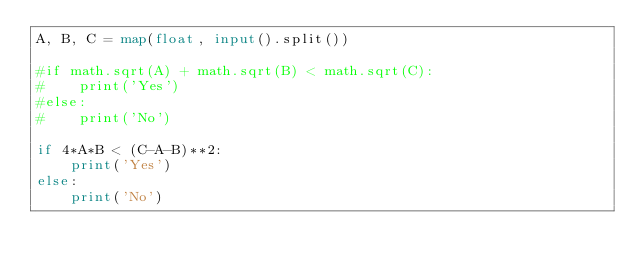Convert code to text. <code><loc_0><loc_0><loc_500><loc_500><_Python_>A, B, C = map(float, input().split())

#if math.sqrt(A) + math.sqrt(B) < math.sqrt(C):
#    print('Yes')
#else:
#    print('No')

if 4*A*B < (C-A-B)**2:
    print('Yes')
else:
    print('No')</code> 